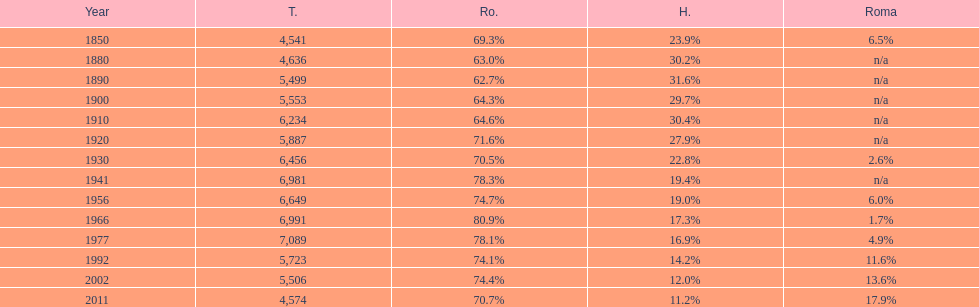Would you mind parsing the complete table? {'header': ['Year', 'T.', 'Ro.', 'H.', 'Roma'], 'rows': [['1850', '4,541', '69.3%', '23.9%', '6.5%'], ['1880', '4,636', '63.0%', '30.2%', 'n/a'], ['1890', '5,499', '62.7%', '31.6%', 'n/a'], ['1900', '5,553', '64.3%', '29.7%', 'n/a'], ['1910', '6,234', '64.6%', '30.4%', 'n/a'], ['1920', '5,887', '71.6%', '27.9%', 'n/a'], ['1930', '6,456', '70.5%', '22.8%', '2.6%'], ['1941', '6,981', '78.3%', '19.4%', 'n/a'], ['1956', '6,649', '74.7%', '19.0%', '6.0%'], ['1966', '6,991', '80.9%', '17.3%', '1.7%'], ['1977', '7,089', '78.1%', '16.9%', '4.9%'], ['1992', '5,723', '74.1%', '14.2%', '11.6%'], ['2002', '5,506', '74.4%', '12.0%', '13.6%'], ['2011', '4,574', '70.7%', '11.2%', '17.9%']]} In which year was the maximum total number recorded? 1977. 